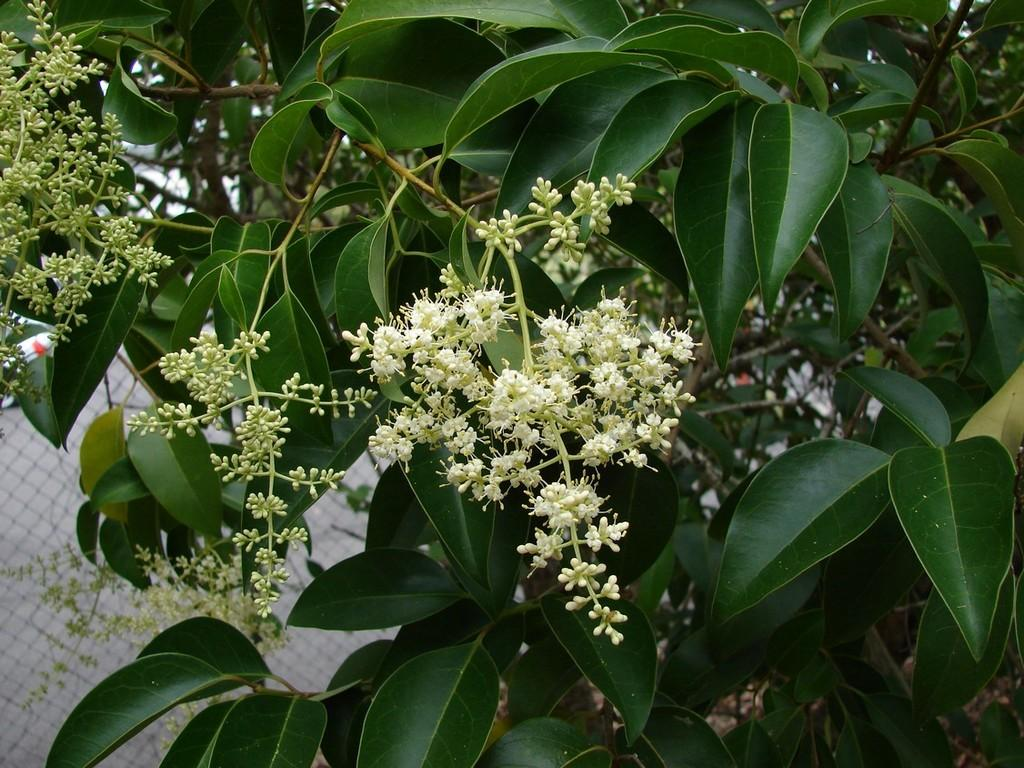What type of plant life is present in the image? There are flowers, buds, and leaves in the image. Can you describe the stage of growth for the plants in the image? The plants in the image have both buds and flowers, indicating various stages of growth. What else can be seen in the image besides the plants? There are other objects in the image. What is visible in the background of the image? There is a fence and other objects in the background of the image. How many wrens are sitting on the fence in the image? There are no wrens present in the image; only flowers, buds, leaves, and other objects are visible. 